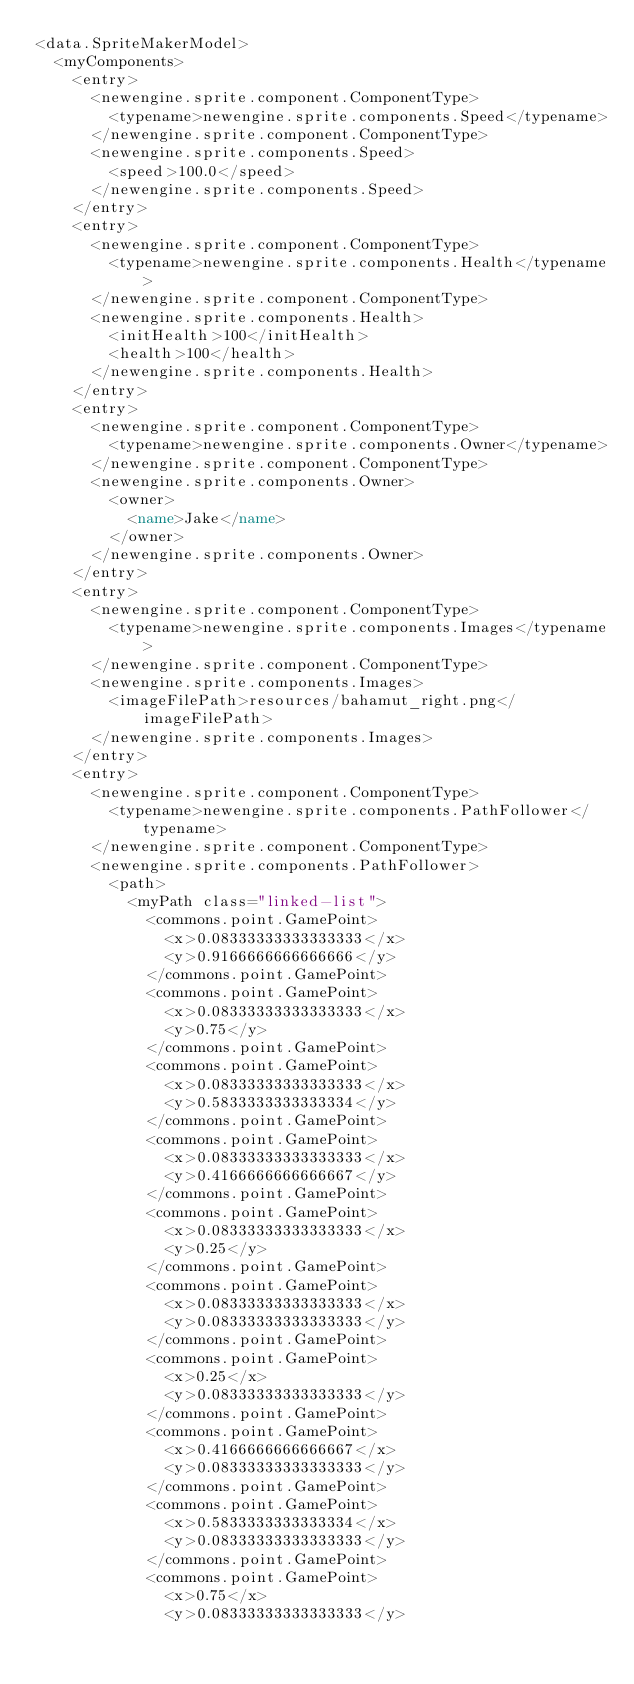<code> <loc_0><loc_0><loc_500><loc_500><_XML_><data.SpriteMakerModel>
  <myComponents>
    <entry>
      <newengine.sprite.component.ComponentType>
        <typename>newengine.sprite.components.Speed</typename>
      </newengine.sprite.component.ComponentType>
      <newengine.sprite.components.Speed>
        <speed>100.0</speed>
      </newengine.sprite.components.Speed>
    </entry>
    <entry>
      <newengine.sprite.component.ComponentType>
        <typename>newengine.sprite.components.Health</typename>
      </newengine.sprite.component.ComponentType>
      <newengine.sprite.components.Health>
        <initHealth>100</initHealth>
        <health>100</health>
      </newengine.sprite.components.Health>
    </entry>
    <entry>
      <newengine.sprite.component.ComponentType>
        <typename>newengine.sprite.components.Owner</typename>
      </newengine.sprite.component.ComponentType>
      <newengine.sprite.components.Owner>
        <owner>
          <name>Jake</name>
        </owner>
      </newengine.sprite.components.Owner>
    </entry>
    <entry>
      <newengine.sprite.component.ComponentType>
        <typename>newengine.sprite.components.Images</typename>
      </newengine.sprite.component.ComponentType>
      <newengine.sprite.components.Images>
        <imageFilePath>resources/bahamut_right.png</imageFilePath>
      </newengine.sprite.components.Images>
    </entry>
    <entry>
      <newengine.sprite.component.ComponentType>
        <typename>newengine.sprite.components.PathFollower</typename>
      </newengine.sprite.component.ComponentType>
      <newengine.sprite.components.PathFollower>
        <path>
          <myPath class="linked-list">
            <commons.point.GamePoint>
              <x>0.08333333333333333</x>
              <y>0.9166666666666666</y>
            </commons.point.GamePoint>
            <commons.point.GamePoint>
              <x>0.08333333333333333</x>
              <y>0.75</y>
            </commons.point.GamePoint>
            <commons.point.GamePoint>
              <x>0.08333333333333333</x>
              <y>0.5833333333333334</y>
            </commons.point.GamePoint>
            <commons.point.GamePoint>
              <x>0.08333333333333333</x>
              <y>0.4166666666666667</y>
            </commons.point.GamePoint>
            <commons.point.GamePoint>
              <x>0.08333333333333333</x>
              <y>0.25</y>
            </commons.point.GamePoint>
            <commons.point.GamePoint>
              <x>0.08333333333333333</x>
              <y>0.08333333333333333</y>
            </commons.point.GamePoint>
            <commons.point.GamePoint>
              <x>0.25</x>
              <y>0.08333333333333333</y>
            </commons.point.GamePoint>
            <commons.point.GamePoint>
              <x>0.4166666666666667</x>
              <y>0.08333333333333333</y>
            </commons.point.GamePoint>
            <commons.point.GamePoint>
              <x>0.5833333333333334</x>
              <y>0.08333333333333333</y>
            </commons.point.GamePoint>
            <commons.point.GamePoint>
              <x>0.75</x>
              <y>0.08333333333333333</y></code> 